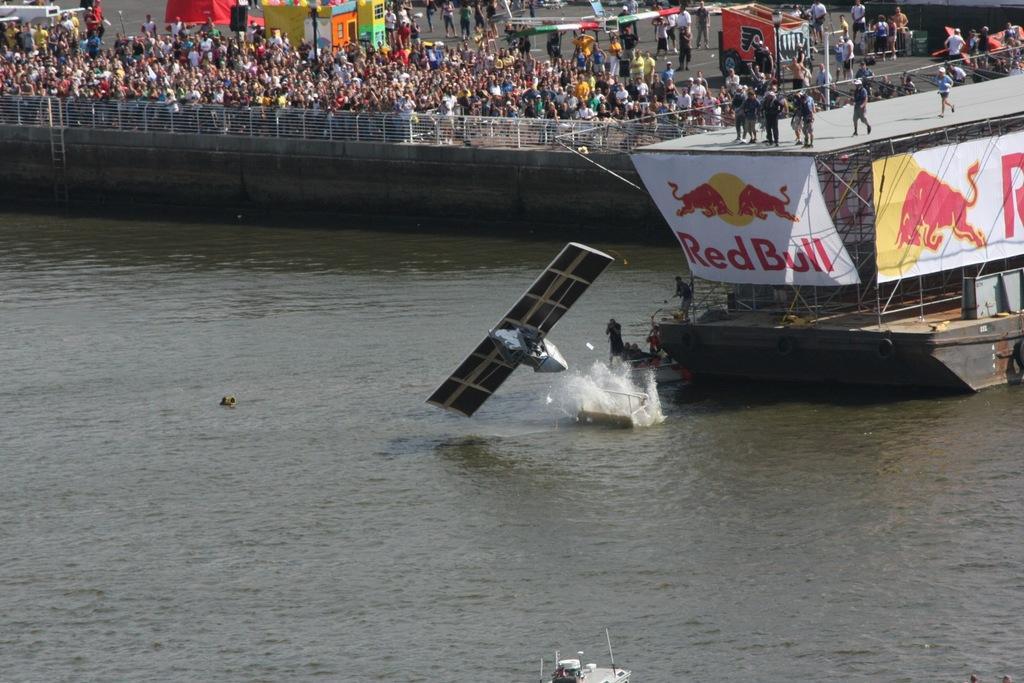Could you give a brief overview of what you see in this image? Here in this picture in the middle we can see a satellite falling into the water present all over there and on the right side we can see a bridge present, on which number of people are standing over there and behind them on the road we can also see number of people standing and watching it and some of them are clicking photographs with cameras in their hand and on the road we can see tents and shops present here and there and on the bridge we can see a banner present over there. 